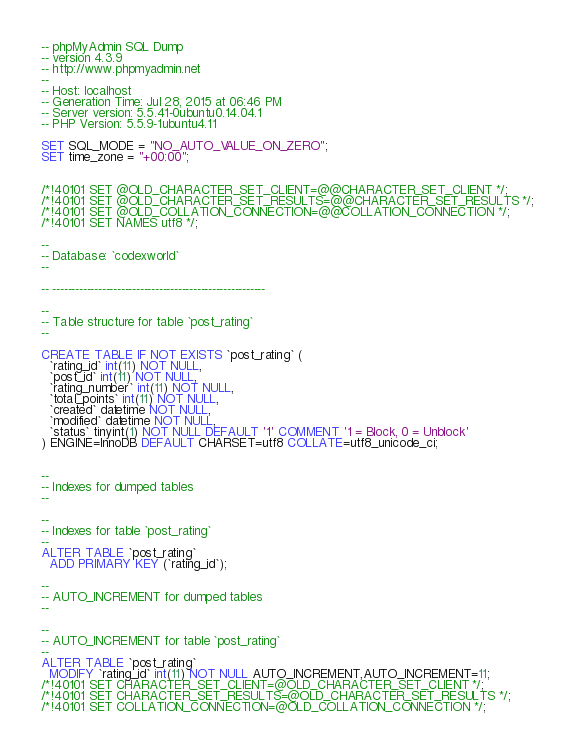<code> <loc_0><loc_0><loc_500><loc_500><_SQL_>-- phpMyAdmin SQL Dump
-- version 4.3.9
-- http://www.phpmyadmin.net
--
-- Host: localhost
-- Generation Time: Jul 28, 2015 at 06:46 PM
-- Server version: 5.5.41-0ubuntu0.14.04.1
-- PHP Version: 5.5.9-1ubuntu4.11

SET SQL_MODE = "NO_AUTO_VALUE_ON_ZERO";
SET time_zone = "+00:00";


/*!40101 SET @OLD_CHARACTER_SET_CLIENT=@@CHARACTER_SET_CLIENT */;
/*!40101 SET @OLD_CHARACTER_SET_RESULTS=@@CHARACTER_SET_RESULTS */;
/*!40101 SET @OLD_COLLATION_CONNECTION=@@COLLATION_CONNECTION */;
/*!40101 SET NAMES utf8 */;

--
-- Database: `codexworld`
--

-- --------------------------------------------------------

--
-- Table structure for table `post_rating`
--

CREATE TABLE IF NOT EXISTS `post_rating` (
  `rating_id` int(11) NOT NULL,
  `post_id` int(11) NOT NULL,
  `rating_number` int(11) NOT NULL,
  `total_points` int(11) NOT NULL,
  `created` datetime NOT NULL,
  `modified` datetime NOT NULL,
  `status` tinyint(1) NOT NULL DEFAULT '1' COMMENT '1 = Block, 0 = Unblock'
) ENGINE=InnoDB DEFAULT CHARSET=utf8 COLLATE=utf8_unicode_ci;


--
-- Indexes for dumped tables
--

--
-- Indexes for table `post_rating`
--
ALTER TABLE `post_rating`
  ADD PRIMARY KEY (`rating_id`);

--
-- AUTO_INCREMENT for dumped tables
--

--
-- AUTO_INCREMENT for table `post_rating`
--
ALTER TABLE `post_rating`
  MODIFY `rating_id` int(11) NOT NULL AUTO_INCREMENT,AUTO_INCREMENT=11;
/*!40101 SET CHARACTER_SET_CLIENT=@OLD_CHARACTER_SET_CLIENT */;
/*!40101 SET CHARACTER_SET_RESULTS=@OLD_CHARACTER_SET_RESULTS */;
/*!40101 SET COLLATION_CONNECTION=@OLD_COLLATION_CONNECTION */;
</code> 